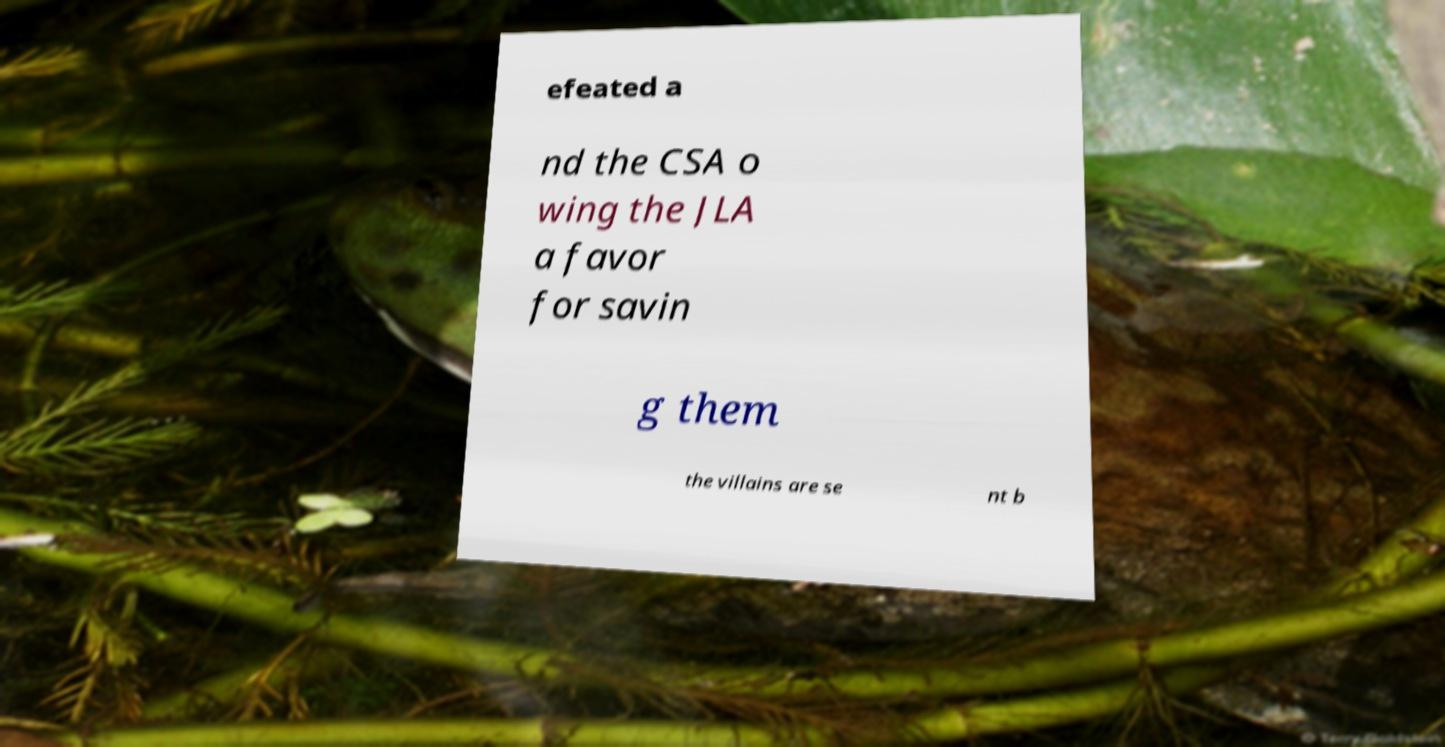What messages or text are displayed in this image? I need them in a readable, typed format. efeated a nd the CSA o wing the JLA a favor for savin g them the villains are se nt b 